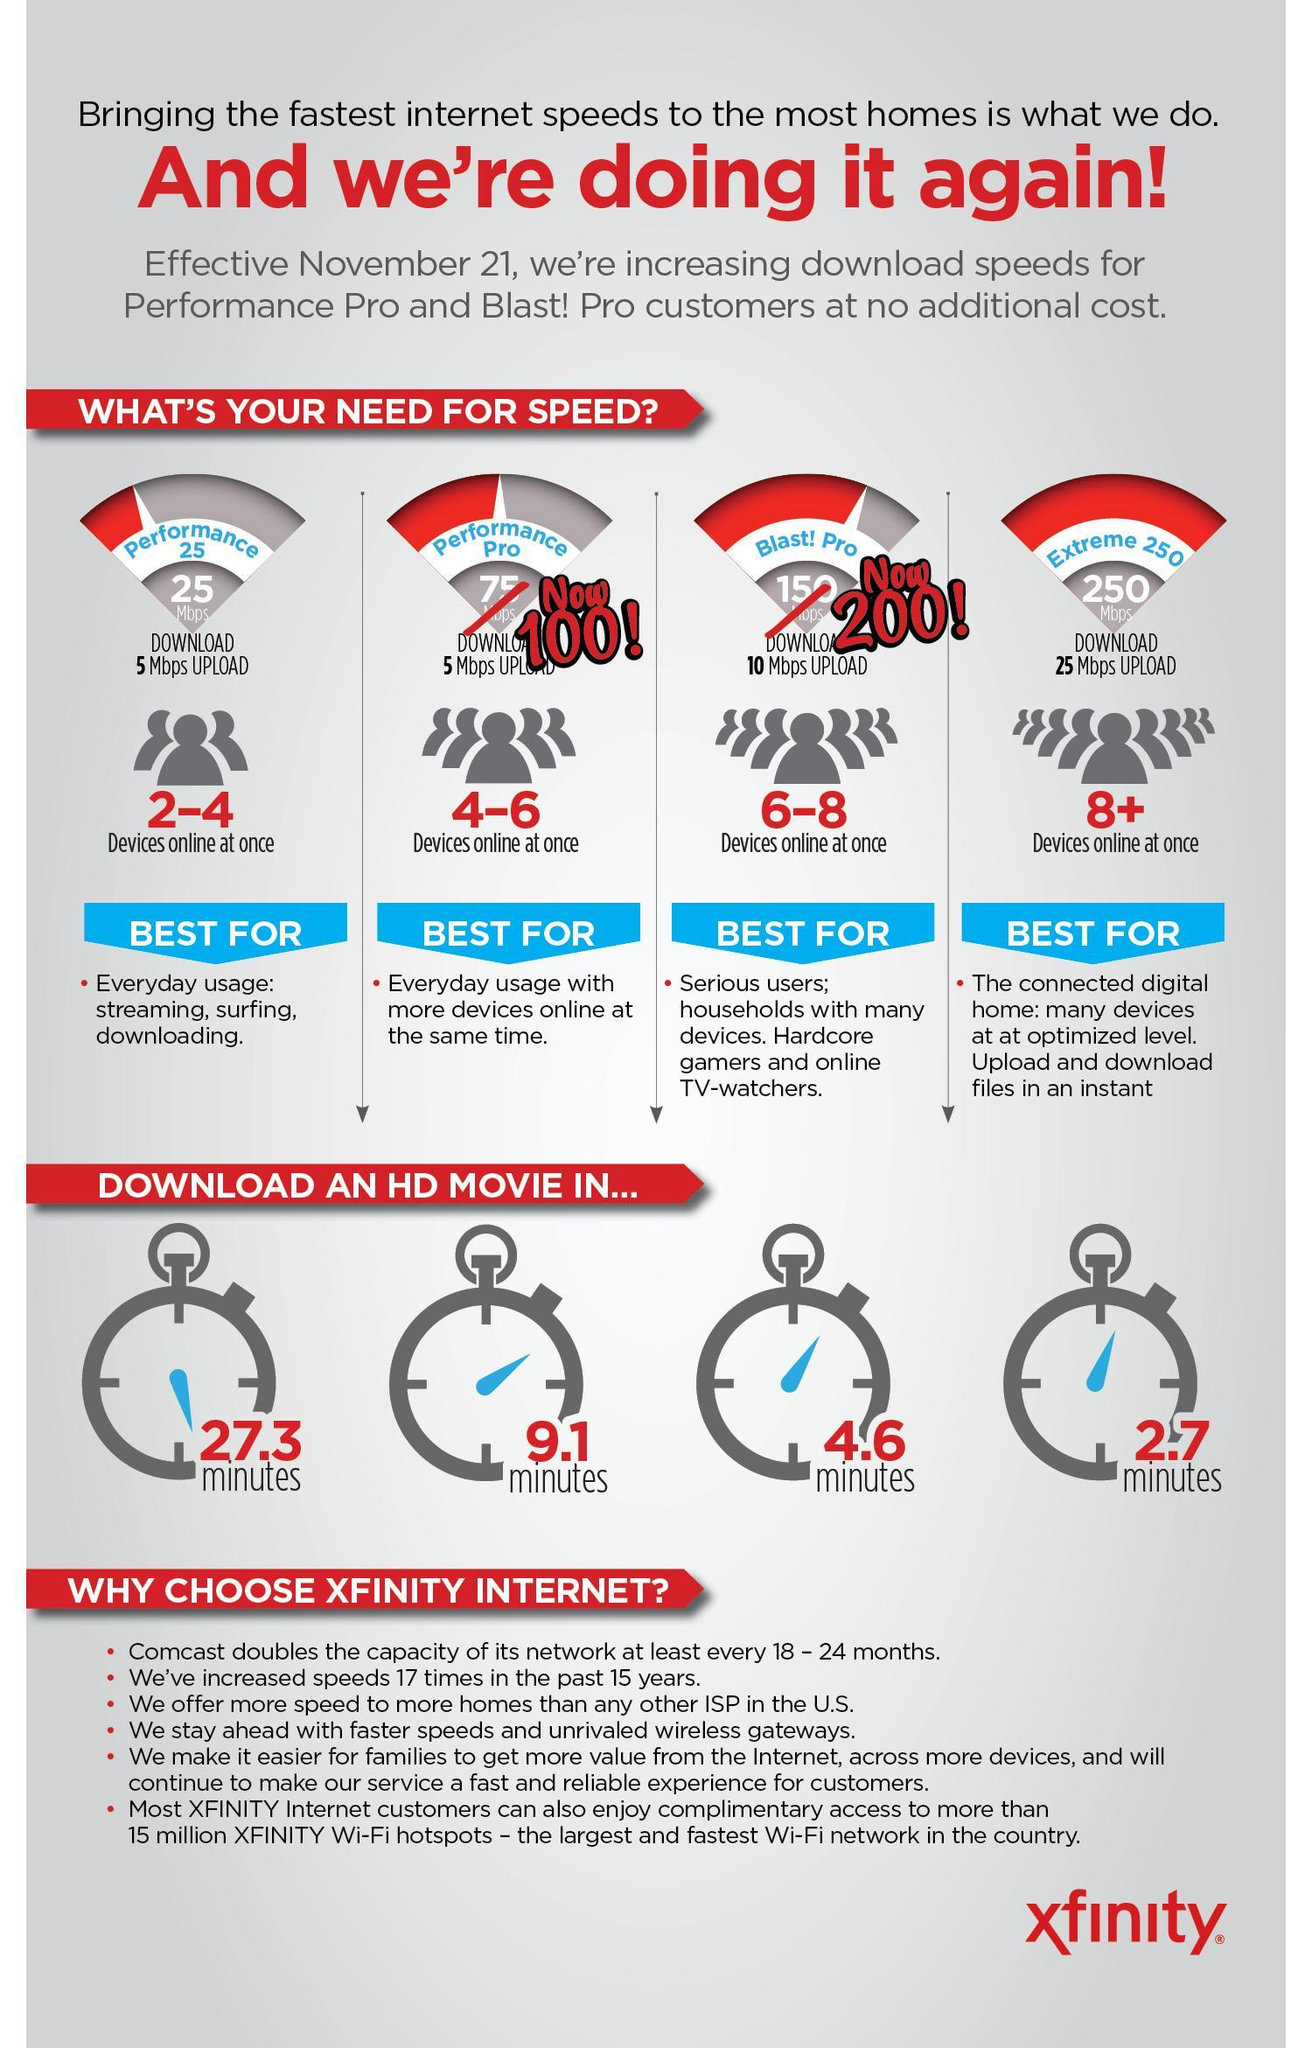Which internet package takes the longest time to download a HD movie?
Answer the question with a short phrase. Performance Pro Which internet packages have 5 Mbps upload speed? Performance 25, Performance Pro Which internet package has takes the least time to download HD movie? Extreme 250 What is the time taken to download a HD movie using Blast!Pro? 4.6 minutes Which internet package has 250 Mbps download speed, Extreme 250, BlastPro, or Performance Pro? Extreme 250 Which was internet package to connect four to six devices, Blast Pro, Performance 25, and Performance Pro? Performance Pro 